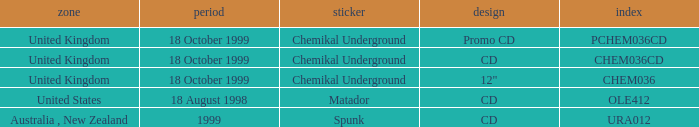What label has a catalog of chem036cd? Chemikal Underground. 